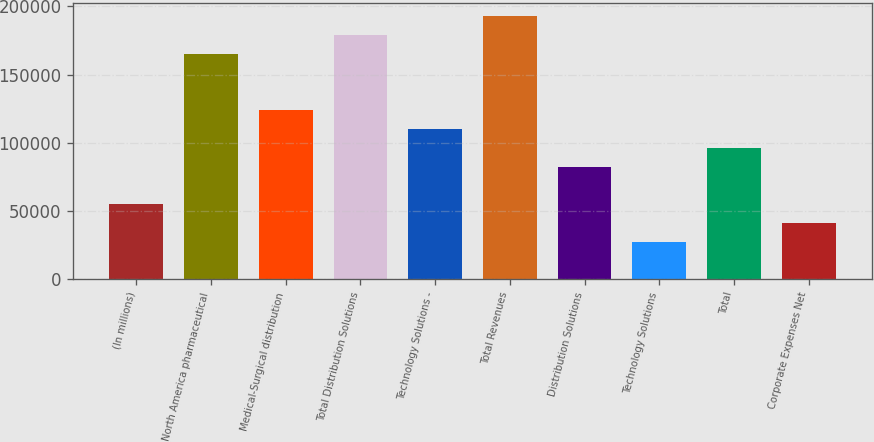Convert chart. <chart><loc_0><loc_0><loc_500><loc_500><bar_chart><fcel>(In millions)<fcel>North America pharmaceutical<fcel>Medical-Surgical distribution<fcel>Total Distribution Solutions<fcel>Technology Solutions -<fcel>Total Revenues<fcel>Distribution Solutions<fcel>Technology Solutions<fcel>Total<fcel>Corporate Expenses Net<nl><fcel>55115.6<fcel>165107<fcel>123860<fcel>178856<fcel>110111<fcel>192605<fcel>82613.4<fcel>27617.8<fcel>96362.3<fcel>41366.7<nl></chart> 